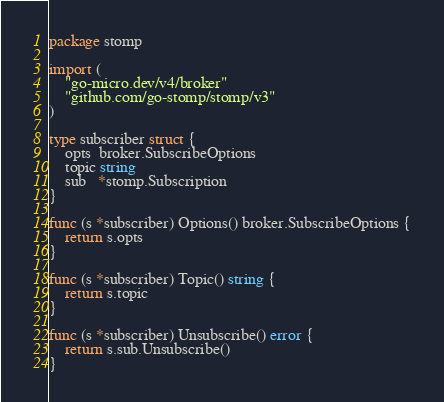Convert code to text. <code><loc_0><loc_0><loc_500><loc_500><_Go_>package stomp

import (
	"go-micro.dev/v4/broker"
	"github.com/go-stomp/stomp/v3"
)

type subscriber struct {
	opts  broker.SubscribeOptions
	topic string
	sub   *stomp.Subscription
}

func (s *subscriber) Options() broker.SubscribeOptions {
	return s.opts
}

func (s *subscriber) Topic() string {
	return s.topic
}

func (s *subscriber) Unsubscribe() error {
	return s.sub.Unsubscribe()
}
</code> 